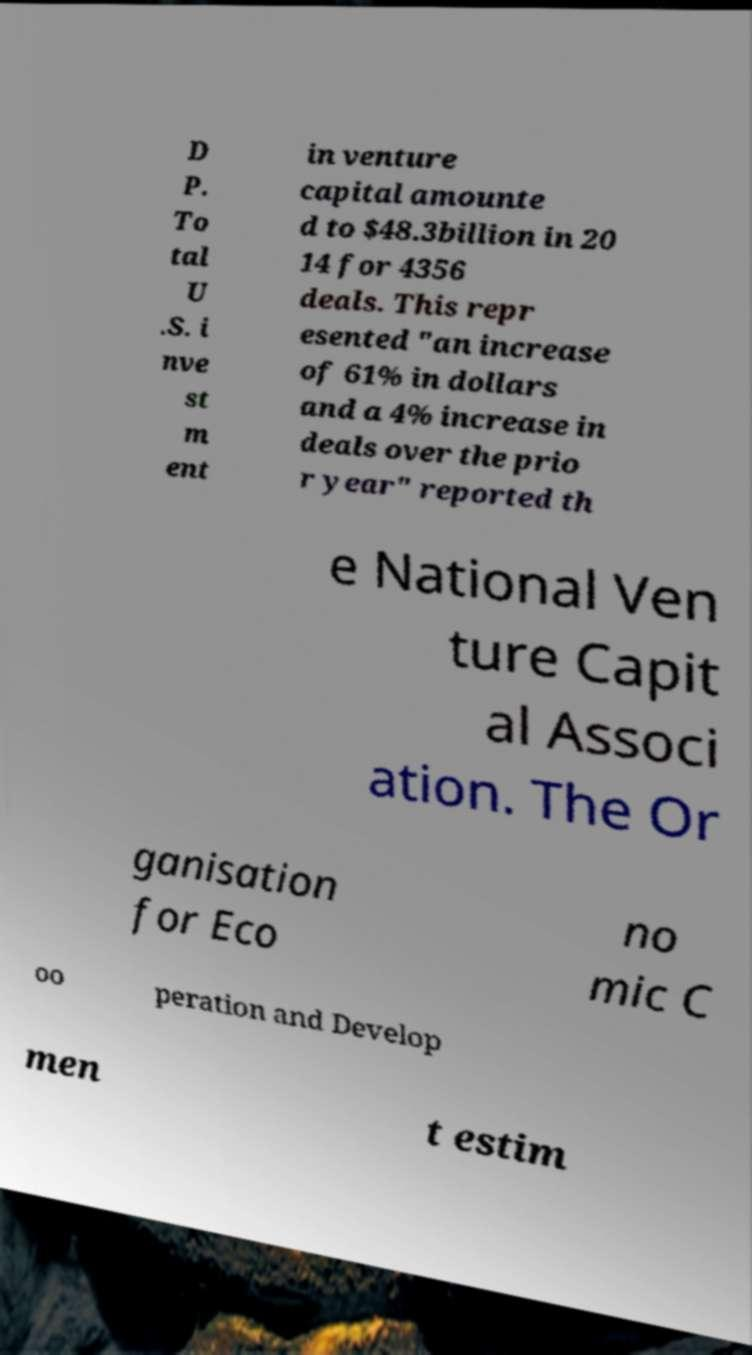Could you extract and type out the text from this image? D P. To tal U .S. i nve st m ent in venture capital amounte d to $48.3billion in 20 14 for 4356 deals. This repr esented "an increase of 61% in dollars and a 4% increase in deals over the prio r year" reported th e National Ven ture Capit al Associ ation. The Or ganisation for Eco no mic C oo peration and Develop men t estim 